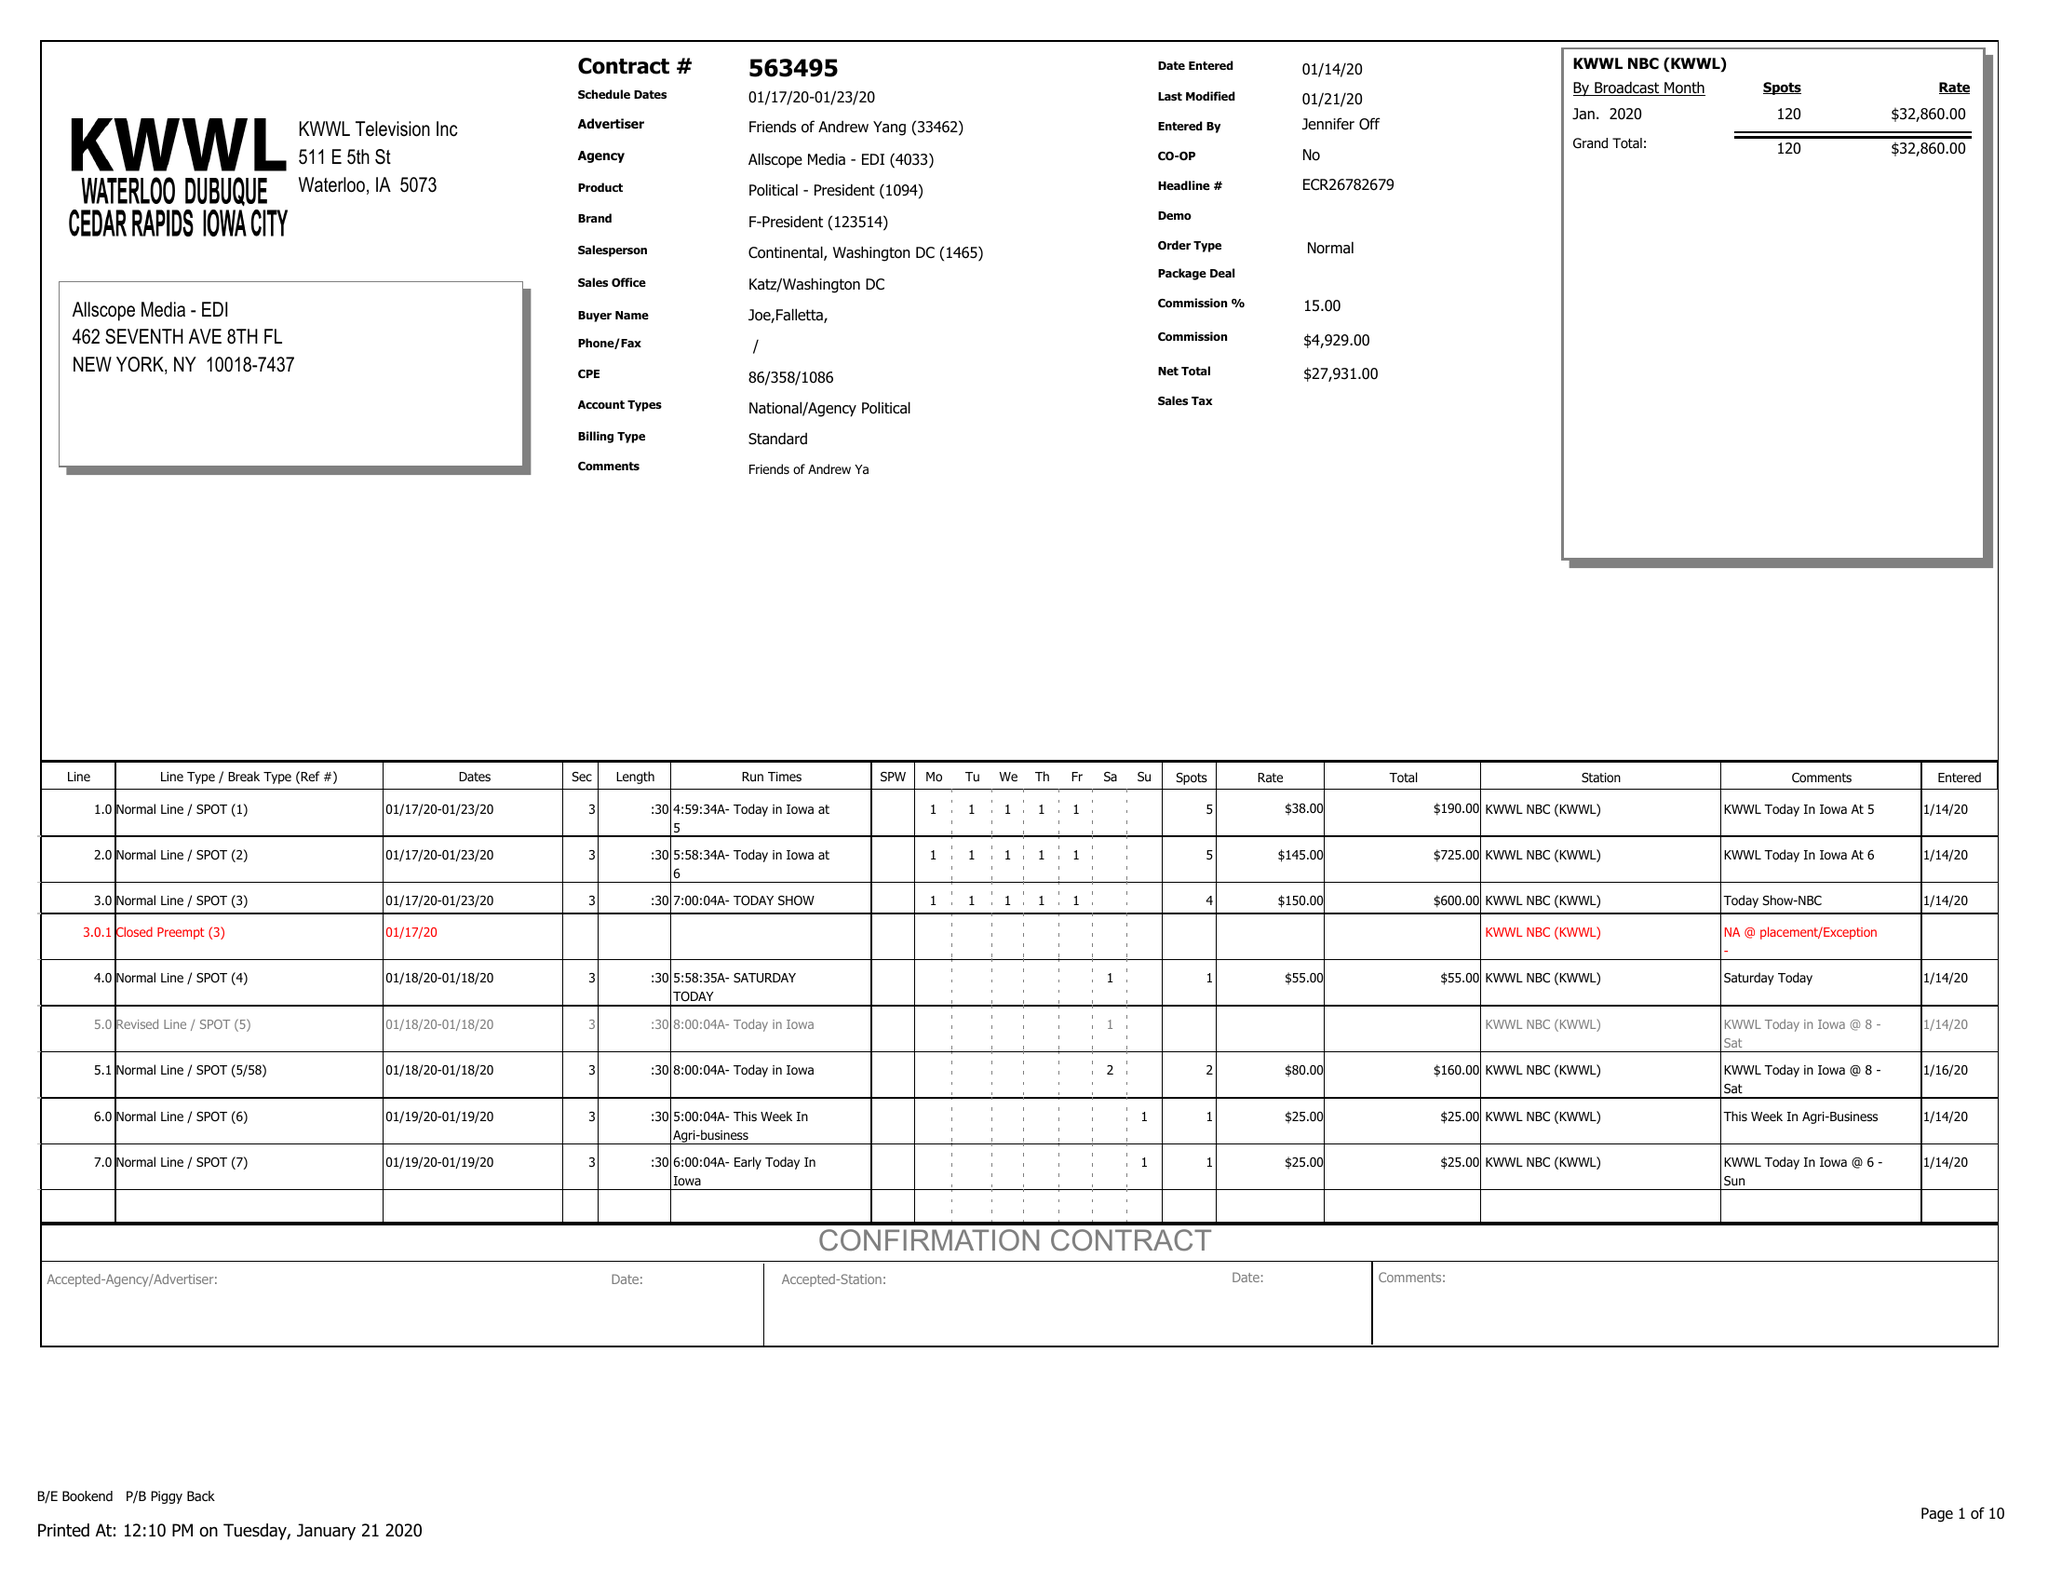What is the value for the flight_from?
Answer the question using a single word or phrase. 01/17/20 